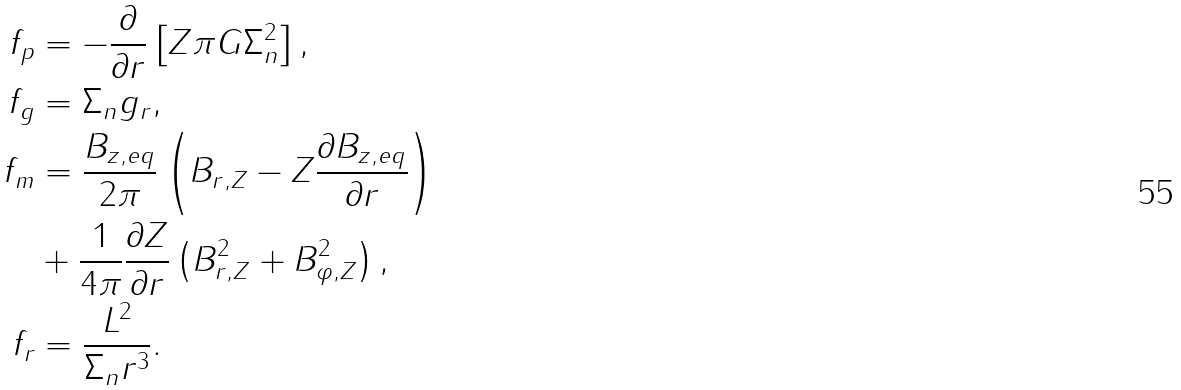<formula> <loc_0><loc_0><loc_500><loc_500>f _ { p } & = - \frac { \partial } { \partial r } \left [ Z \pi G \Sigma _ { n } ^ { 2 } \right ] , \\ f _ { g } & = \Sigma _ { n } g _ { r } , \\ f _ { m } & = \frac { B _ { z , e q } } { 2 \pi } \left ( B _ { r , Z } - Z \frac { \partial B _ { z , e q } } { \partial r } \right ) \\ & + \frac { 1 } { 4 \pi } \frac { \partial Z } { \partial r } \left ( B _ { r , Z } ^ { 2 } + B _ { \varphi , Z } ^ { 2 } \right ) , \\ f _ { r } & = \frac { L ^ { 2 } } { \Sigma _ { n } r ^ { 3 } } .</formula> 